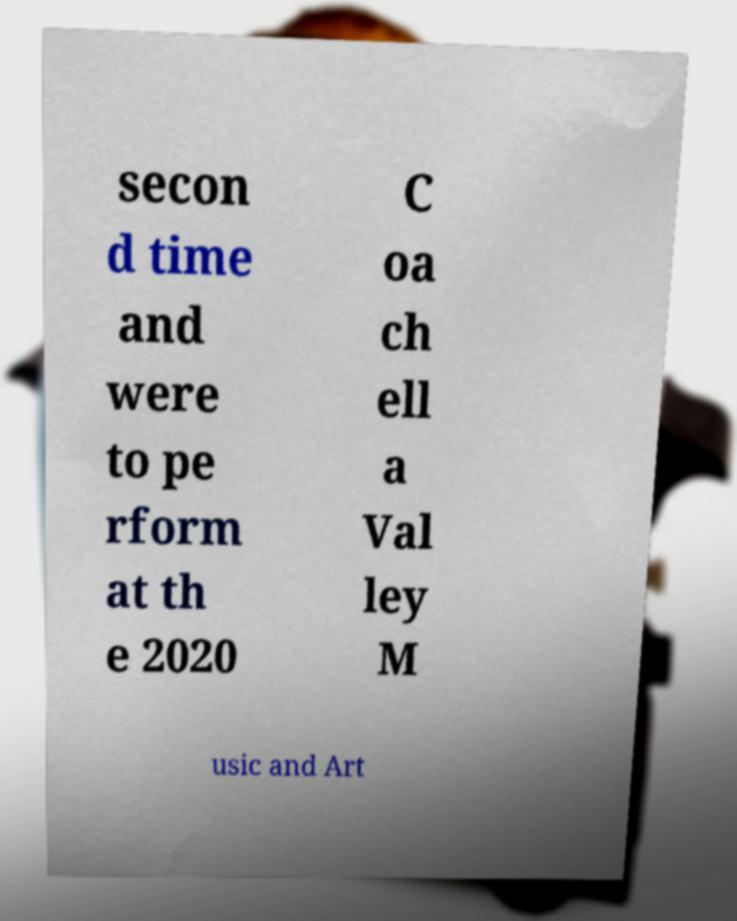What messages or text are displayed in this image? I need them in a readable, typed format. secon d time and were to pe rform at th e 2020 C oa ch ell a Val ley M usic and Art 